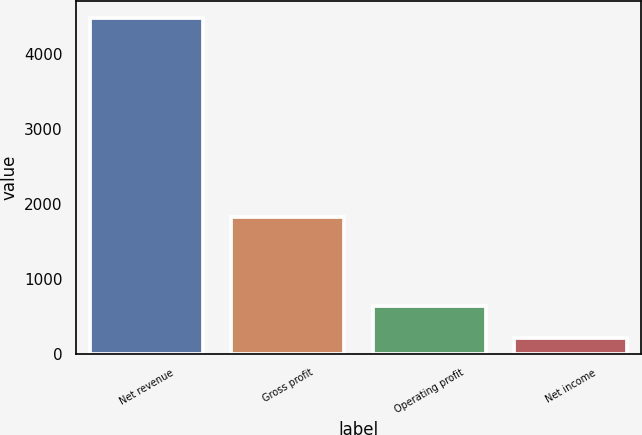Convert chart to OTSL. <chart><loc_0><loc_0><loc_500><loc_500><bar_chart><fcel>Net revenue<fcel>Gross profit<fcel>Operating profit<fcel>Net income<nl><fcel>4480<fcel>1823<fcel>638.8<fcel>212<nl></chart> 